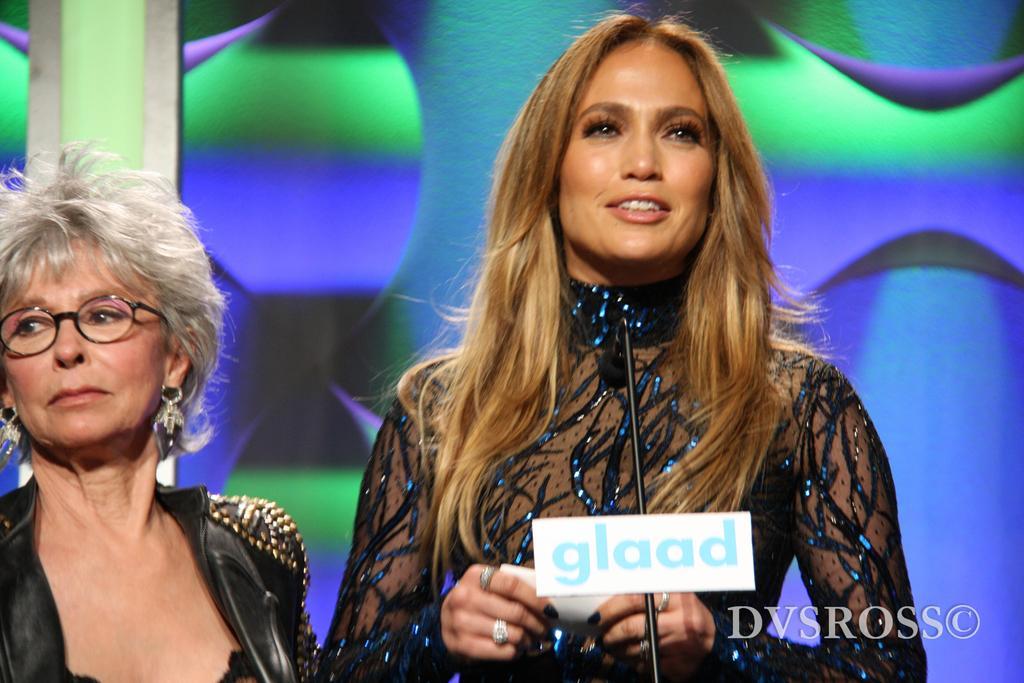In one or two sentences, can you explain what this image depicts? In this image we can see two women. One woman is holding a paper in her hand. In the foreground we can see a microphone with a board and text on it. In the background, we can see a screen. At the bottom we can see some text. 